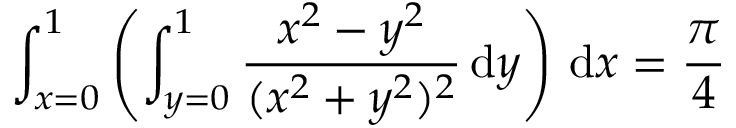<formula> <loc_0><loc_0><loc_500><loc_500>\int _ { x = 0 } ^ { 1 } \left ( \int _ { y = 0 } ^ { 1 } { \frac { x ^ { 2 } - y ^ { 2 } } { ( x ^ { 2 } + y ^ { 2 } ) ^ { 2 } } } \, { d } y \right ) \, { d } x = { \frac { \pi } { 4 } }</formula> 